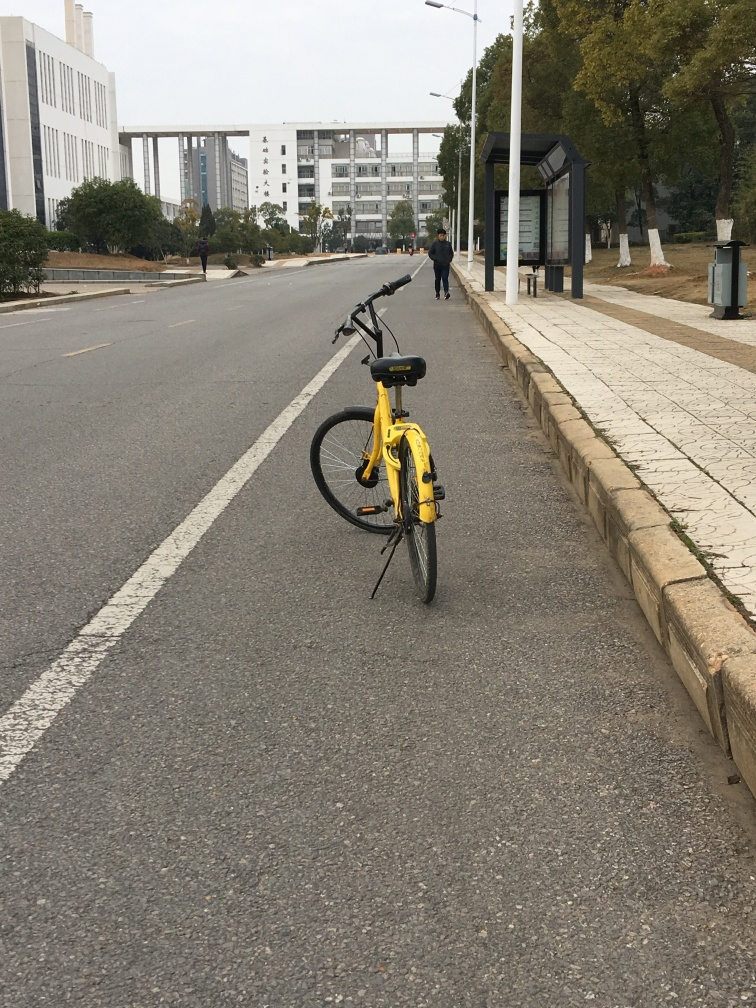Is the photo of good quality? Yes, the photo is of good quality as it maintains clear focus, proper exposure, and adequate sharpness to discern details such as the texture of the road, buildings in the background, and the design of the bicycle. 